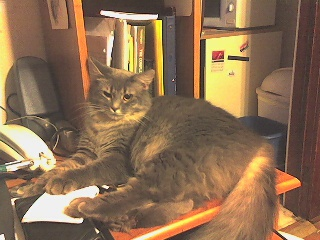Describe the objects in this image and their specific colors. I can see cat in tan and gray tones, microwave in tan, gray, and black tones, book in tan, maroon, gold, and orange tones, book in tan, gray, darkgreen, and black tones, and book in tan, brown, and ivory tones in this image. 